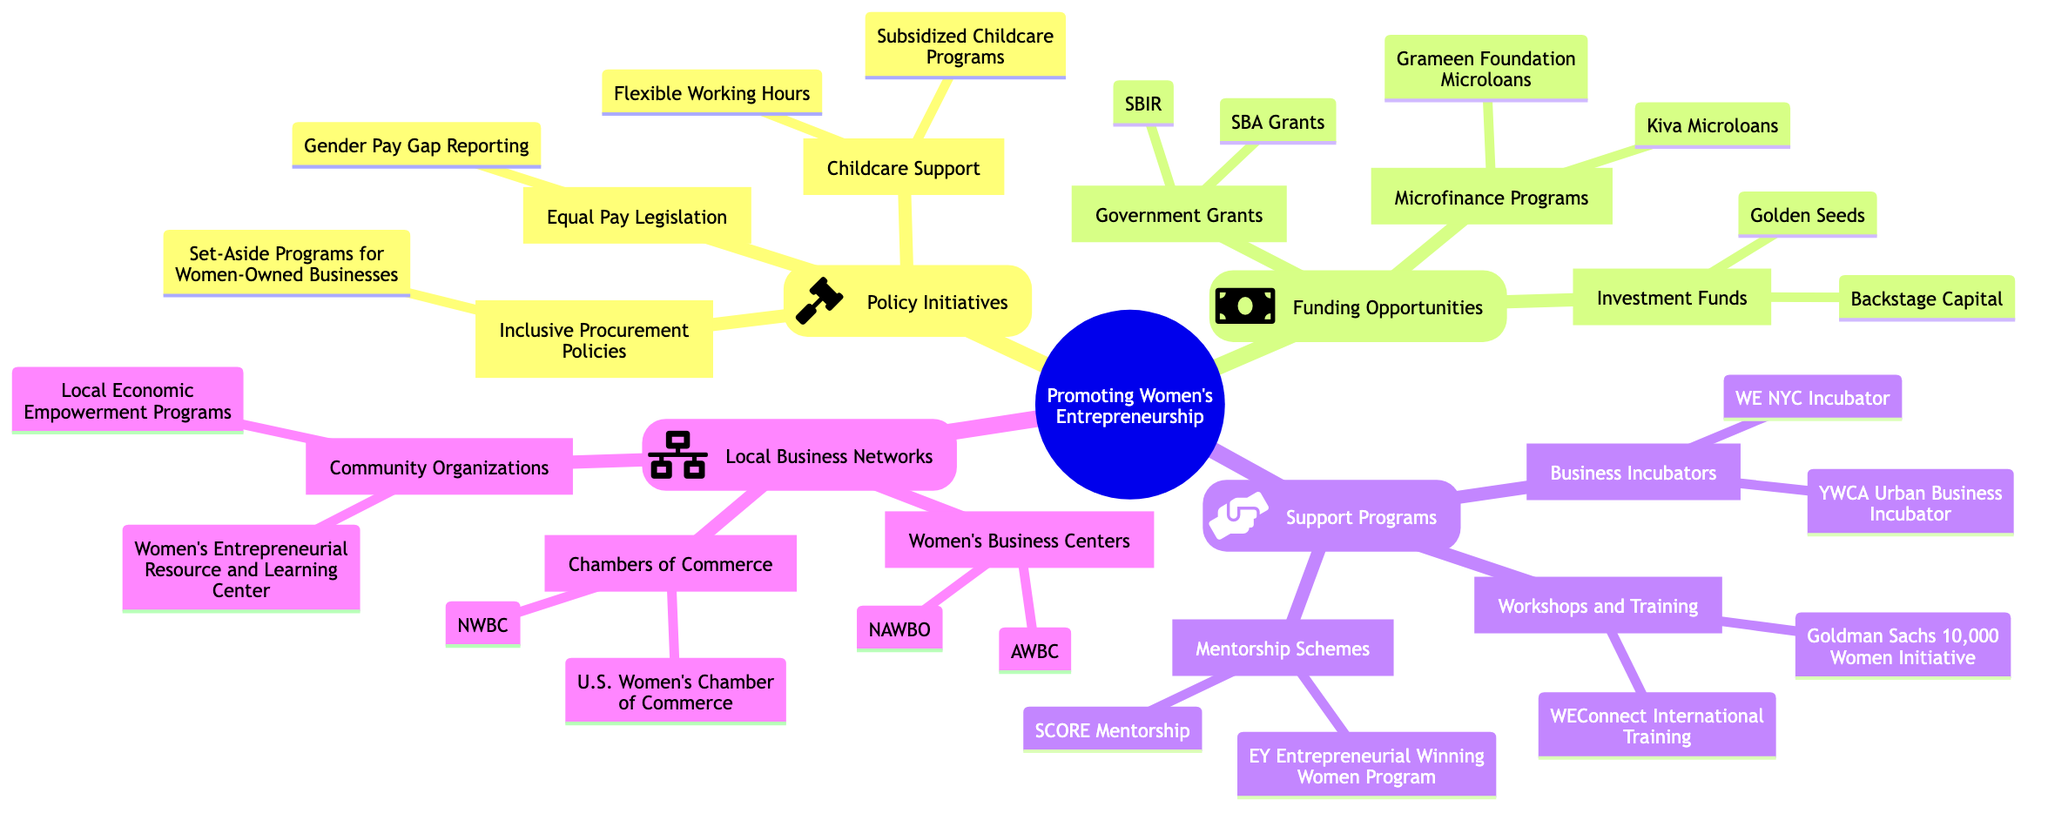What are the three main categories under promoting women's entrepreneurship? The mind map outlines four main categories: Policy Initiatives, Funding Opportunities, Support Programs, and Local Business Networks.
Answer: Policy Initiatives, Funding Opportunities, Support Programs, Local Business Networks How many types of funding opportunities are listed in the diagram? The diagram shows three types of funding opportunities: Government Grants, Microfinance Programs, and Investment Funds.
Answer: Three What is one program listed under mentorship schemes? Under the Support Programs category, one of the programs listed under Mentorship Schemes is the EY Entrepreneurial Winning Women Program.
Answer: EY Entrepreneurial Winning Women Program What initiative is associated with subsidized childcare programs? The initiative associated with Subsidized Childcare Programs falls under Policy Initiatives, which is Childcare Support.
Answer: Childcare Support How many organizations are mentioned under Local Business Networks? There are three subcategories under Local Business Networks: Women's Business Centers, Chambers of Commerce, and Community Organizations. Each of these has two examples, making a total of six specific organizations mentioned.
Answer: Six What is the focus of the Goldman Sachs initiative listed in the diagram? The Goldman Sachs initiative is categorized under Workshops and Training, specifically as part of the Goldman Sachs 10,000 Women Initiative. This shows it focuses on providing training to women entrepreneurs.
Answer: Workshops and Training What specific procurement policy is aimed at supporting women-owned businesses? The specific procurement policy aimed at supporting women-owned businesses is Set-Aside Programs for Women-Owned Businesses, which is classified under Inclusive Procurement Policies.
Answer: Set-Aside Programs for Women-Owned Businesses Which investment fund is named in the funding opportunities? The mind map lists Golden Seeds as one of the investment funds available in the Funding Opportunities category.
Answer: Golden Seeds What type of organization is the U.S. Women's Chamber of Commerce? The U.S. Women's Chamber of Commerce is categorized under Chambers of Commerce within the Local Business Networks section.
Answer: Chambers of Commerce 